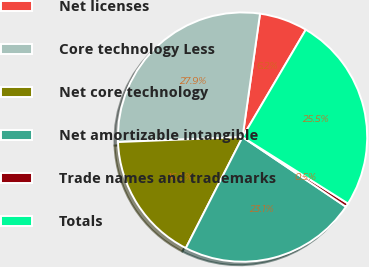<chart> <loc_0><loc_0><loc_500><loc_500><pie_chart><fcel>Net licenses<fcel>Core technology Less<fcel>Net core technology<fcel>Net amortizable intangible<fcel>Trade names and trademarks<fcel>Totals<nl><fcel>6.23%<fcel>27.88%<fcel>16.85%<fcel>23.08%<fcel>0.49%<fcel>25.48%<nl></chart> 